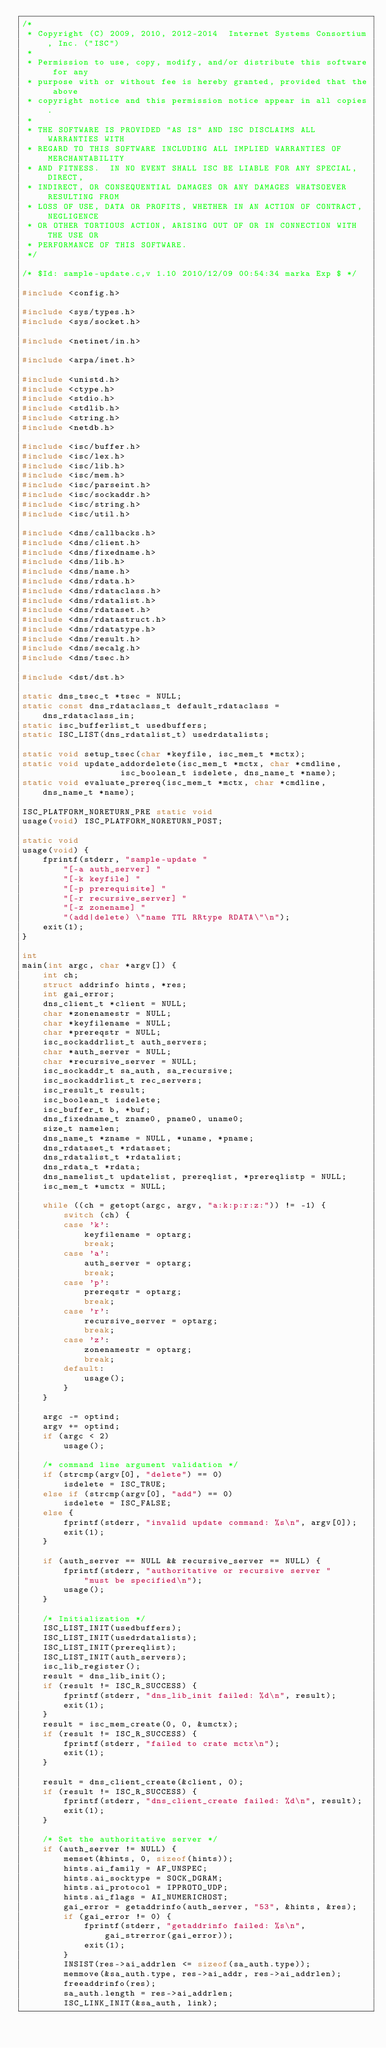<code> <loc_0><loc_0><loc_500><loc_500><_C_>/*
 * Copyright (C) 2009, 2010, 2012-2014  Internet Systems Consortium, Inc. ("ISC")
 *
 * Permission to use, copy, modify, and/or distribute this software for any
 * purpose with or without fee is hereby granted, provided that the above
 * copyright notice and this permission notice appear in all copies.
 *
 * THE SOFTWARE IS PROVIDED "AS IS" AND ISC DISCLAIMS ALL WARRANTIES WITH
 * REGARD TO THIS SOFTWARE INCLUDING ALL IMPLIED WARRANTIES OF MERCHANTABILITY
 * AND FITNESS.  IN NO EVENT SHALL ISC BE LIABLE FOR ANY SPECIAL, DIRECT,
 * INDIRECT, OR CONSEQUENTIAL DAMAGES OR ANY DAMAGES WHATSOEVER RESULTING FROM
 * LOSS OF USE, DATA OR PROFITS, WHETHER IN AN ACTION OF CONTRACT, NEGLIGENCE
 * OR OTHER TORTIOUS ACTION, ARISING OUT OF OR IN CONNECTION WITH THE USE OR
 * PERFORMANCE OF THIS SOFTWARE.
 */

/* $Id: sample-update.c,v 1.10 2010/12/09 00:54:34 marka Exp $ */

#include <config.h>

#include <sys/types.h>
#include <sys/socket.h>

#include <netinet/in.h>

#include <arpa/inet.h>

#include <unistd.h>
#include <ctype.h>
#include <stdio.h>
#include <stdlib.h>
#include <string.h>
#include <netdb.h>

#include <isc/buffer.h>
#include <isc/lex.h>
#include <isc/lib.h>
#include <isc/mem.h>
#include <isc/parseint.h>
#include <isc/sockaddr.h>
#include <isc/string.h>
#include <isc/util.h>

#include <dns/callbacks.h>
#include <dns/client.h>
#include <dns/fixedname.h>
#include <dns/lib.h>
#include <dns/name.h>
#include <dns/rdata.h>
#include <dns/rdataclass.h>
#include <dns/rdatalist.h>
#include <dns/rdataset.h>
#include <dns/rdatastruct.h>
#include <dns/rdatatype.h>
#include <dns/result.h>
#include <dns/secalg.h>
#include <dns/tsec.h>

#include <dst/dst.h>

static dns_tsec_t *tsec = NULL;
static const dns_rdataclass_t default_rdataclass = dns_rdataclass_in;
static isc_bufferlist_t usedbuffers;
static ISC_LIST(dns_rdatalist_t) usedrdatalists;

static void setup_tsec(char *keyfile, isc_mem_t *mctx);
static void update_addordelete(isc_mem_t *mctx, char *cmdline,
			       isc_boolean_t isdelete, dns_name_t *name);
static void evaluate_prereq(isc_mem_t *mctx, char *cmdline, dns_name_t *name);

ISC_PLATFORM_NORETURN_PRE static void
usage(void) ISC_PLATFORM_NORETURN_POST;

static void
usage(void) {
	fprintf(stderr, "sample-update "
		"[-a auth_server] "
		"[-k keyfile] "
		"[-p prerequisite] "
		"[-r recursive_server] "
		"[-z zonename] "
		"(add|delete) \"name TTL RRtype RDATA\"\n");
	exit(1);
}

int
main(int argc, char *argv[]) {
	int ch;
	struct addrinfo hints, *res;
	int gai_error;
	dns_client_t *client = NULL;
	char *zonenamestr = NULL;
	char *keyfilename = NULL;
	char *prereqstr = NULL;
	isc_sockaddrlist_t auth_servers;
	char *auth_server = NULL;
	char *recursive_server = NULL;
	isc_sockaddr_t sa_auth, sa_recursive;
	isc_sockaddrlist_t rec_servers;
	isc_result_t result;
	isc_boolean_t isdelete;
	isc_buffer_t b, *buf;
	dns_fixedname_t zname0, pname0, uname0;
	size_t namelen;
	dns_name_t *zname = NULL, *uname, *pname;
	dns_rdataset_t *rdataset;
	dns_rdatalist_t *rdatalist;
	dns_rdata_t *rdata;
	dns_namelist_t updatelist, prereqlist, *prereqlistp = NULL;
	isc_mem_t *umctx = NULL;

	while ((ch = getopt(argc, argv, "a:k:p:r:z:")) != -1) {
		switch (ch) {
		case 'k':
			keyfilename = optarg;
			break;
		case 'a':
			auth_server = optarg;
			break;
		case 'p':
			prereqstr = optarg;
			break;
		case 'r':
			recursive_server = optarg;
			break;
		case 'z':
			zonenamestr = optarg;
			break;
		default:
			usage();
		}
	}

	argc -= optind;
	argv += optind;
	if (argc < 2)
		usage();

	/* command line argument validation */
	if (strcmp(argv[0], "delete") == 0)
		isdelete = ISC_TRUE;
	else if (strcmp(argv[0], "add") == 0)
		isdelete = ISC_FALSE;
	else {
		fprintf(stderr, "invalid update command: %s\n", argv[0]);
		exit(1);
	}

	if (auth_server == NULL && recursive_server == NULL) {
		fprintf(stderr, "authoritative or recursive server "
			"must be specified\n");
		usage();
	}

	/* Initialization */
	ISC_LIST_INIT(usedbuffers);
	ISC_LIST_INIT(usedrdatalists);
	ISC_LIST_INIT(prereqlist);
	ISC_LIST_INIT(auth_servers);
	isc_lib_register();
	result = dns_lib_init();
	if (result != ISC_R_SUCCESS) {
		fprintf(stderr, "dns_lib_init failed: %d\n", result);
		exit(1);
	}
	result = isc_mem_create(0, 0, &umctx);
	if (result != ISC_R_SUCCESS) {
		fprintf(stderr, "failed to crate mctx\n");
		exit(1);
	}

	result = dns_client_create(&client, 0);
	if (result != ISC_R_SUCCESS) {
		fprintf(stderr, "dns_client_create failed: %d\n", result);
		exit(1);
	}

	/* Set the authoritative server */
	if (auth_server != NULL) {
		memset(&hints, 0, sizeof(hints));
		hints.ai_family = AF_UNSPEC;
		hints.ai_socktype = SOCK_DGRAM;
		hints.ai_protocol = IPPROTO_UDP;
		hints.ai_flags = AI_NUMERICHOST;
		gai_error = getaddrinfo(auth_server, "53", &hints, &res);
		if (gai_error != 0) {
			fprintf(stderr, "getaddrinfo failed: %s\n",
				gai_strerror(gai_error));
			exit(1);
		}
		INSIST(res->ai_addrlen <= sizeof(sa_auth.type));
		memmove(&sa_auth.type, res->ai_addr, res->ai_addrlen);
		freeaddrinfo(res);
		sa_auth.length = res->ai_addrlen;
		ISC_LINK_INIT(&sa_auth, link);
</code> 